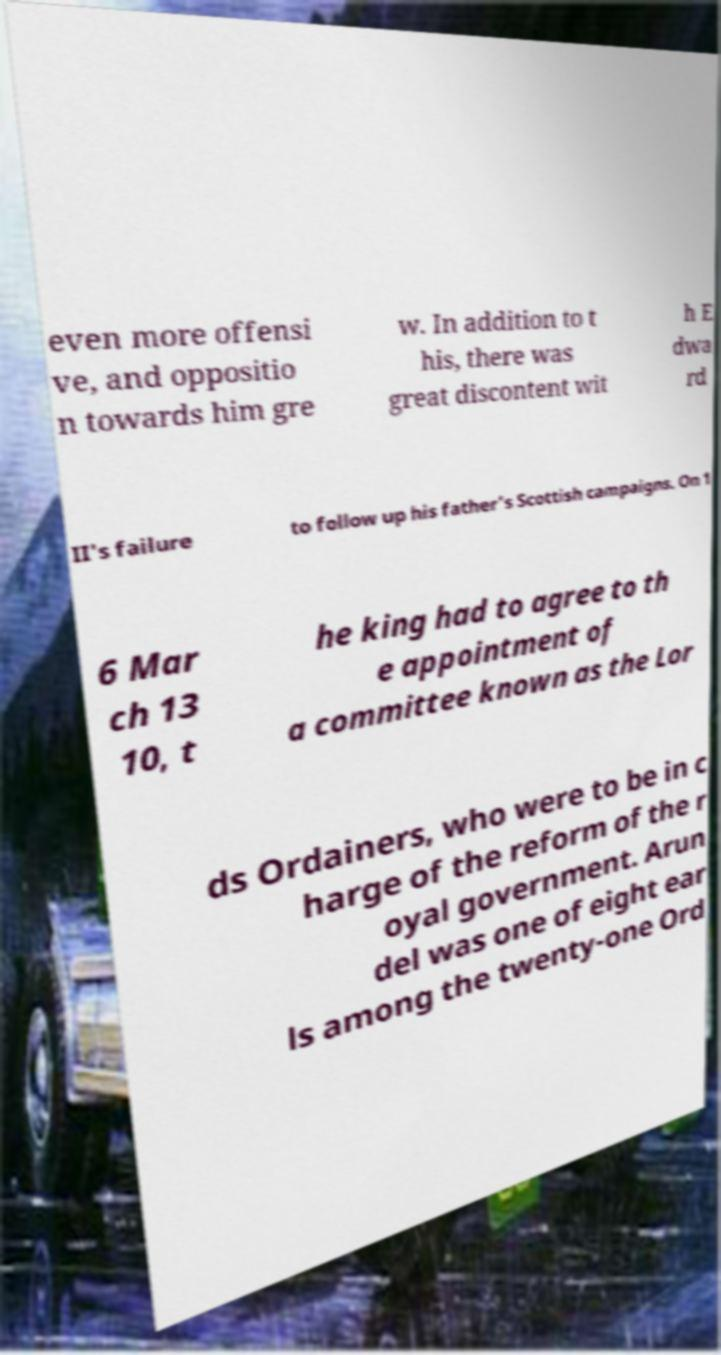There's text embedded in this image that I need extracted. Can you transcribe it verbatim? even more offensi ve, and oppositio n towards him gre w. In addition to t his, there was great discontent wit h E dwa rd II's failure to follow up his father's Scottish campaigns. On 1 6 Mar ch 13 10, t he king had to agree to th e appointment of a committee known as the Lor ds Ordainers, who were to be in c harge of the reform of the r oyal government. Arun del was one of eight ear ls among the twenty-one Ord 